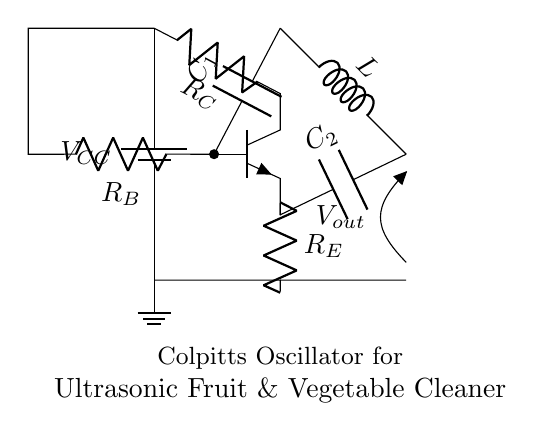What is the power supply voltage in the circuit? The circuit includes a battery labeled as V_CC, which indicates the power supply voltage for the circuit components. The actual voltage value is not provided, but it generally refers to the voltage provided to the circuit.
Answer: V_CC What type of transistor is used in this circuit? The circuit shows an npn transistor symbol, which is a type of bipolar junction transistor commonly used for switching and amplification.
Answer: npn How many resistors are present in the Colpitts oscillator circuit? The diagram shows three resistors: R_C, R_B, and R_E, which are part of the transistor biasing and stability in the circuit.
Answer: three What components are responsible for the oscillation in this Colpitts oscillator circuit? The oscillation is primarily generated by the combination of the inductor L and the capacitors C_1 and C_2, which form a resonant circuit, allowing for oscillations at a certain frequency.
Answer: L, C_1, C_2 What is the output voltage designation in the circuit? The output voltage is indicated as V_out, which is the voltage taken from the circuit, typically at the collector of the transistor, and represents the oscillating signal generated by the circuit.
Answer: V_out What is the function of the capacitor C_1 in this oscillator? Capacitor C_1 is connected to the base of the transistor, helping to couple the oscillating signal from the transistor, influencing the frequency of oscillation and stability of the circuit.
Answer: coupling 